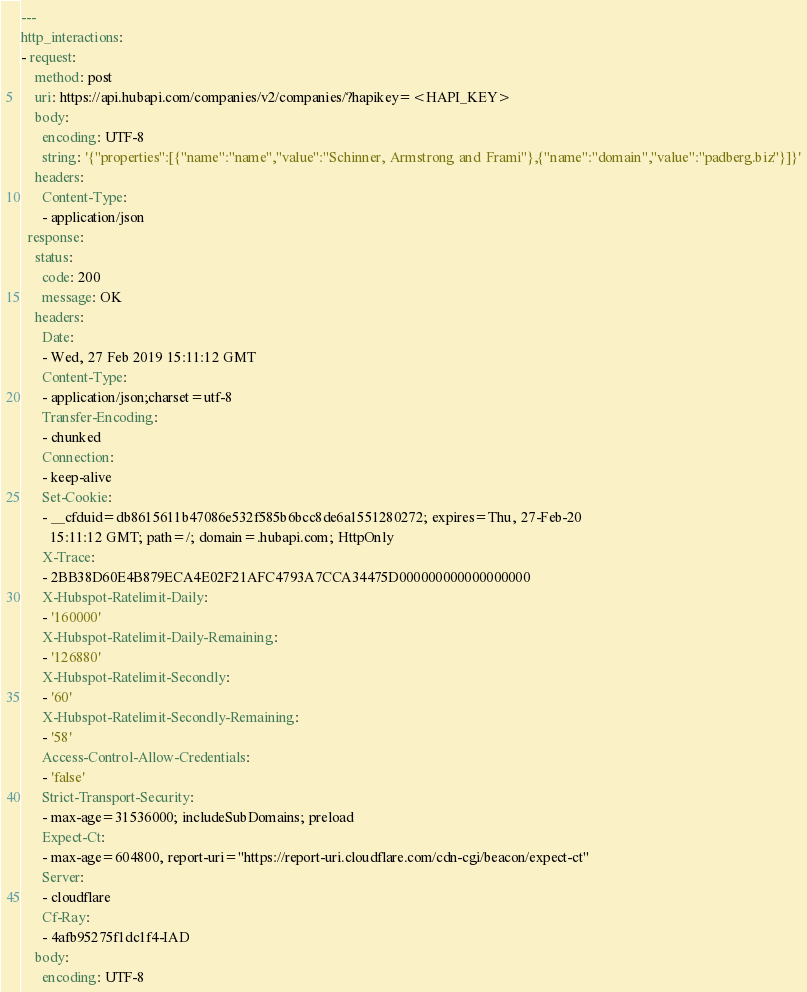<code> <loc_0><loc_0><loc_500><loc_500><_YAML_>---
http_interactions:
- request:
    method: post
    uri: https://api.hubapi.com/companies/v2/companies/?hapikey=<HAPI_KEY>
    body:
      encoding: UTF-8
      string: '{"properties":[{"name":"name","value":"Schinner, Armstrong and Frami"},{"name":"domain","value":"padberg.biz"}]}'
    headers:
      Content-Type:
      - application/json
  response:
    status:
      code: 200
      message: OK
    headers:
      Date:
      - Wed, 27 Feb 2019 15:11:12 GMT
      Content-Type:
      - application/json;charset=utf-8
      Transfer-Encoding:
      - chunked
      Connection:
      - keep-alive
      Set-Cookie:
      - __cfduid=db8615611b47086e532f585b6bcc8de6a1551280272; expires=Thu, 27-Feb-20
        15:11:12 GMT; path=/; domain=.hubapi.com; HttpOnly
      X-Trace:
      - 2BB38D60E4B879ECA4E02F21AFC4793A7CCA34475D000000000000000000
      X-Hubspot-Ratelimit-Daily:
      - '160000'
      X-Hubspot-Ratelimit-Daily-Remaining:
      - '126880'
      X-Hubspot-Ratelimit-Secondly:
      - '60'
      X-Hubspot-Ratelimit-Secondly-Remaining:
      - '58'
      Access-Control-Allow-Credentials:
      - 'false'
      Strict-Transport-Security:
      - max-age=31536000; includeSubDomains; preload
      Expect-Ct:
      - max-age=604800, report-uri="https://report-uri.cloudflare.com/cdn-cgi/beacon/expect-ct"
      Server:
      - cloudflare
      Cf-Ray:
      - 4afb95275f1dc1f4-IAD
    body:
      encoding: UTF-8</code> 